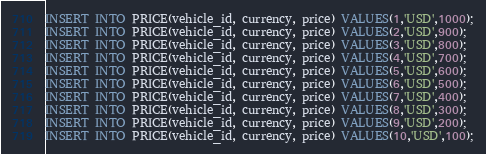Convert code to text. <code><loc_0><loc_0><loc_500><loc_500><_SQL_>INSERT INTO PRICE(vehicle_id, currency, price) VALUES(1,'USD',1000);
INSERT INTO PRICE(vehicle_id, currency, price) VALUES(2,'USD',900);
INSERT INTO PRICE(vehicle_id, currency, price) VALUES(3,'USD',800);
INSERT INTO PRICE(vehicle_id, currency, price) VALUES(4,'USD',700);
INSERT INTO PRICE(vehicle_id, currency, price) VALUES(5,'USD',600);
INSERT INTO PRICE(vehicle_id, currency, price) VALUES(6,'USD',500);
INSERT INTO PRICE(vehicle_id, currency, price) VALUES(7,'USD',400);
INSERT INTO PRICE(vehicle_id, currency, price) VALUES(8,'USD',300);
INSERT INTO PRICE(vehicle_id, currency, price) VALUES(9,'USD',200);
INSERT INTO PRICE(vehicle_id, currency, price) VALUES(10,'USD',100);</code> 